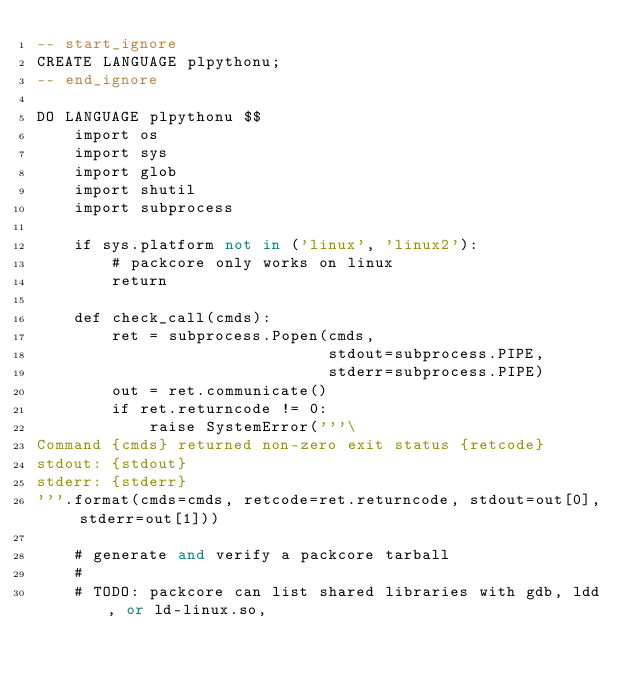Convert code to text. <code><loc_0><loc_0><loc_500><loc_500><_SQL_>-- start_ignore
CREATE LANGUAGE plpythonu;
-- end_ignore

DO LANGUAGE plpythonu $$
    import os
    import sys
    import glob
    import shutil
    import subprocess

    if sys.platform not in ('linux', 'linux2'):
        # packcore only works on linux
        return

    def check_call(cmds):
        ret = subprocess.Popen(cmds,
                               stdout=subprocess.PIPE,
                               stderr=subprocess.PIPE)
        out = ret.communicate()
        if ret.returncode != 0:
            raise SystemError('''\
Command {cmds} returned non-zero exit status {retcode}
stdout: {stdout}
stderr: {stderr}
'''.format(cmds=cmds, retcode=ret.returncode, stdout=out[0], stderr=out[1]))

    # generate and verify a packcore tarball
    #
    # TODO: packcore can list shared libraries with gdb, ldd, or ld-linux.so,</code> 